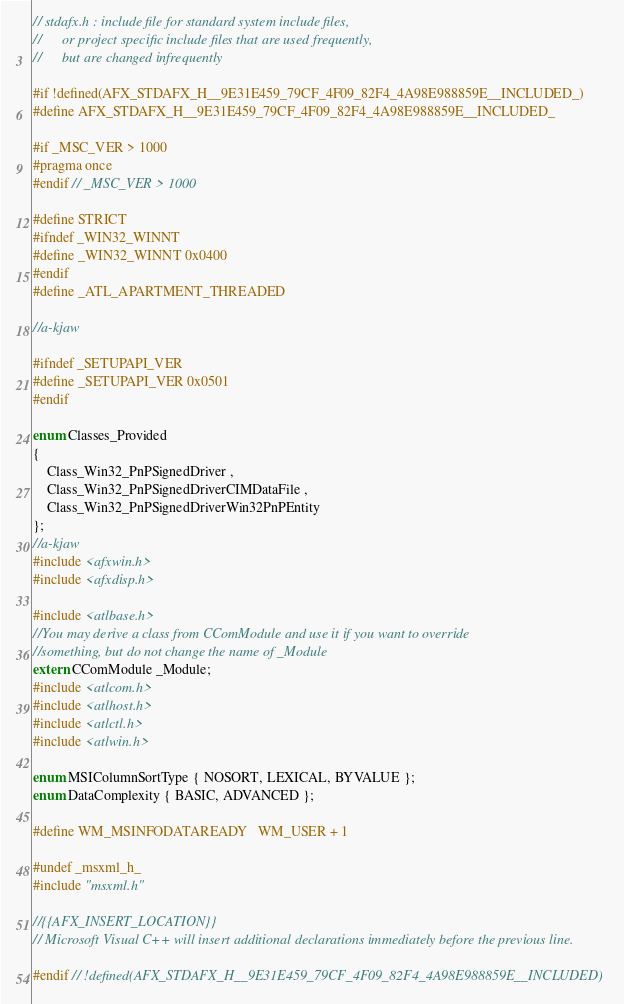Convert code to text. <code><loc_0><loc_0><loc_500><loc_500><_C_>// stdafx.h : include file for standard system include files,
//      or project specific include files that are used frequently,
//      but are changed infrequently

#if !defined(AFX_STDAFX_H__9E31E459_79CF_4F09_82F4_4A98E988859E__INCLUDED_)
#define AFX_STDAFX_H__9E31E459_79CF_4F09_82F4_4A98E988859E__INCLUDED_

#if _MSC_VER > 1000
#pragma once
#endif // _MSC_VER > 1000

#define STRICT
#ifndef _WIN32_WINNT
#define _WIN32_WINNT 0x0400
#endif
#define _ATL_APARTMENT_THREADED

//a-kjaw

#ifndef _SETUPAPI_VER 
#define _SETUPAPI_VER 0x0501
#endif

enum Classes_Provided 
{
	Class_Win32_PnPSignedDriver , 
	Class_Win32_PnPSignedDriverCIMDataFile , 
	Class_Win32_PnPSignedDriverWin32PnPEntity
};
//a-kjaw
#include <afxwin.h>
#include <afxdisp.h>

#include <atlbase.h>
//You may derive a class from CComModule and use it if you want to override
//something, but do not change the name of _Module
extern CComModule _Module;
#include <atlcom.h>
#include <atlhost.h>
#include <atlctl.h>
#include <atlwin.h>

enum MSIColumnSortType { NOSORT, LEXICAL, BYVALUE };
enum DataComplexity { BASIC, ADVANCED };

#define WM_MSINFODATAREADY	WM_USER + 1

#undef _msxml_h_
#include "msxml.h"

//{{AFX_INSERT_LOCATION}}
// Microsoft Visual C++ will insert additional declarations immediately before the previous line.

#endif // !defined(AFX_STDAFX_H__9E31E459_79CF_4F09_82F4_4A98E988859E__INCLUDED)
</code> 